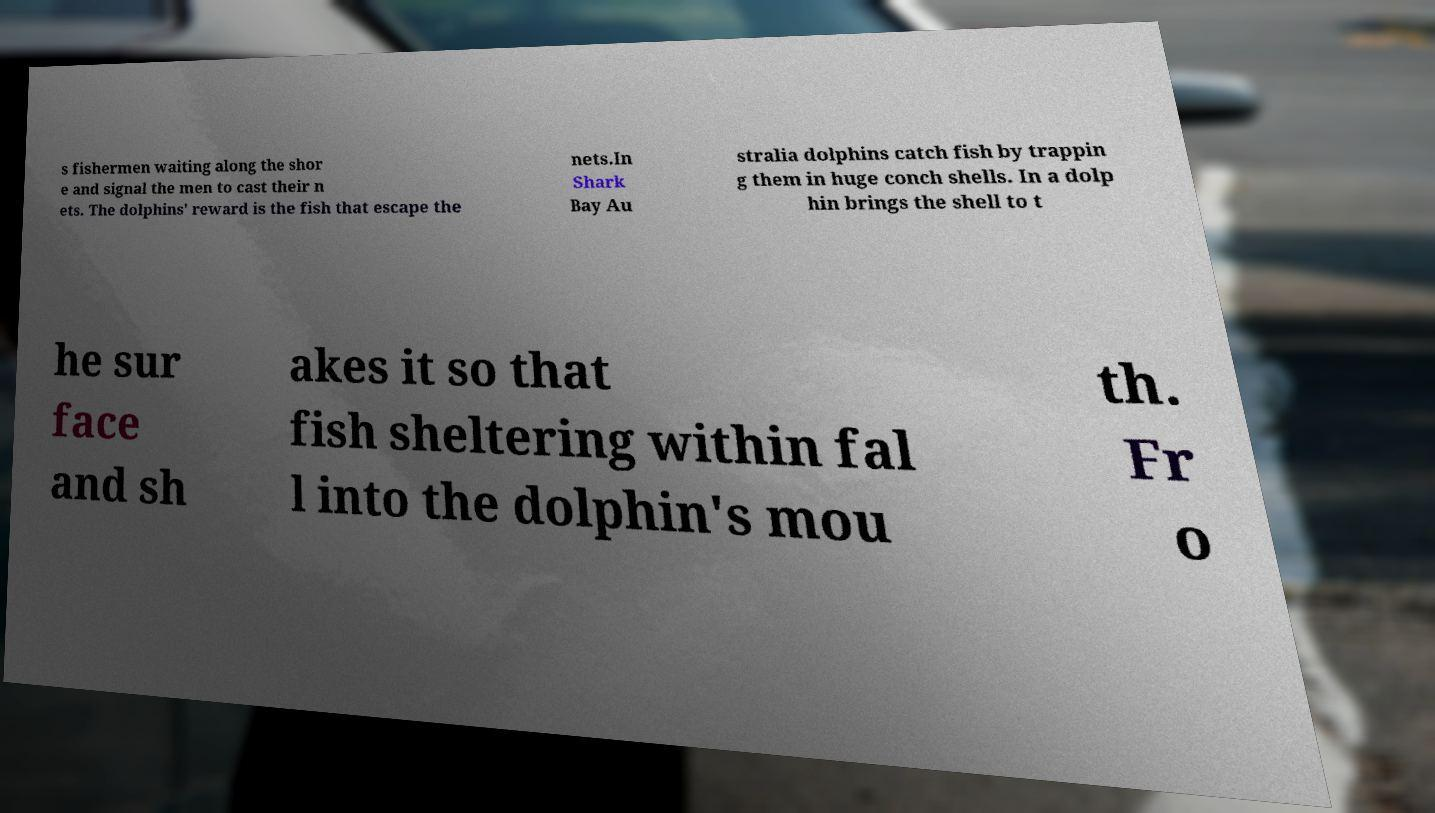I need the written content from this picture converted into text. Can you do that? s fishermen waiting along the shor e and signal the men to cast their n ets. The dolphins' reward is the fish that escape the nets.In Shark Bay Au stralia dolphins catch fish by trappin g them in huge conch shells. In a dolp hin brings the shell to t he sur face and sh akes it so that fish sheltering within fal l into the dolphin's mou th. Fr o 